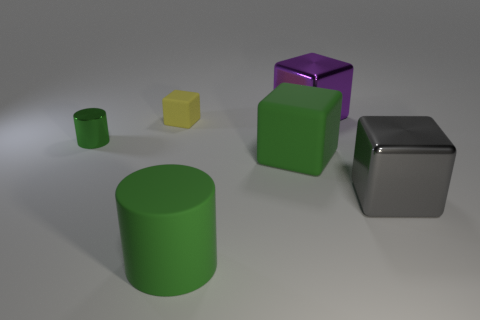Is the material of the big green cylinder the same as the cylinder that is behind the gray shiny object?
Offer a very short reply. No. What shape is the matte object that is the same color as the large rubber cylinder?
Provide a short and direct response. Cube. What number of green matte objects are the same size as the rubber cylinder?
Provide a succinct answer. 1. Are there fewer large gray blocks in front of the gray thing than tiny blue shiny cubes?
Your response must be concise. No. What number of big objects are on the left side of the yellow rubber block?
Keep it short and to the point. 0. There is a green object behind the big green matte thing on the right side of the green thing that is in front of the large gray cube; what is its size?
Keep it short and to the point. Small. Does the tiny green metal thing have the same shape as the large metal thing in front of the small yellow thing?
Provide a succinct answer. No. The green cylinder that is made of the same material as the gray object is what size?
Keep it short and to the point. Small. Is there any other thing of the same color as the small matte thing?
Ensure brevity in your answer.  No. What material is the cylinder behind the large metal object that is to the right of the large metal object that is left of the large gray metal block made of?
Your answer should be compact. Metal. 